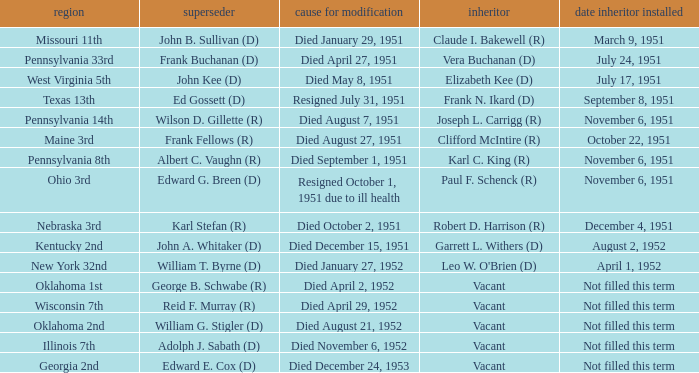How many vacators were in the Pennsylvania 33rd district? 1.0. 